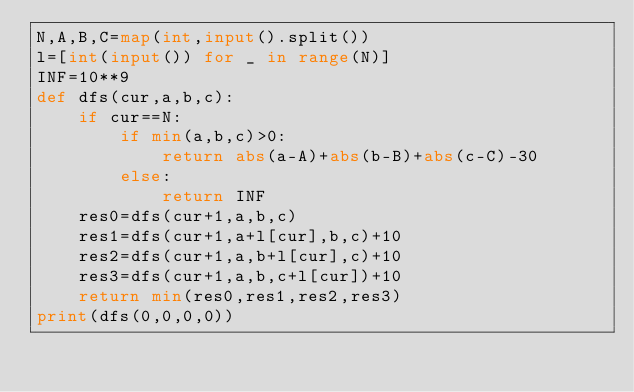<code> <loc_0><loc_0><loc_500><loc_500><_Python_>N,A,B,C=map(int,input().split())
l=[int(input()) for _ in range(N)]
INF=10**9
def dfs(cur,a,b,c):
    if cur==N:
        if min(a,b,c)>0:
            return abs(a-A)+abs(b-B)+abs(c-C)-30
        else:
            return INF
    res0=dfs(cur+1,a,b,c)
    res1=dfs(cur+1,a+l[cur],b,c)+10
    res2=dfs(cur+1,a,b+l[cur],c)+10
    res3=dfs(cur+1,a,b,c+l[cur])+10
    return min(res0,res1,res2,res3)
print(dfs(0,0,0,0))</code> 